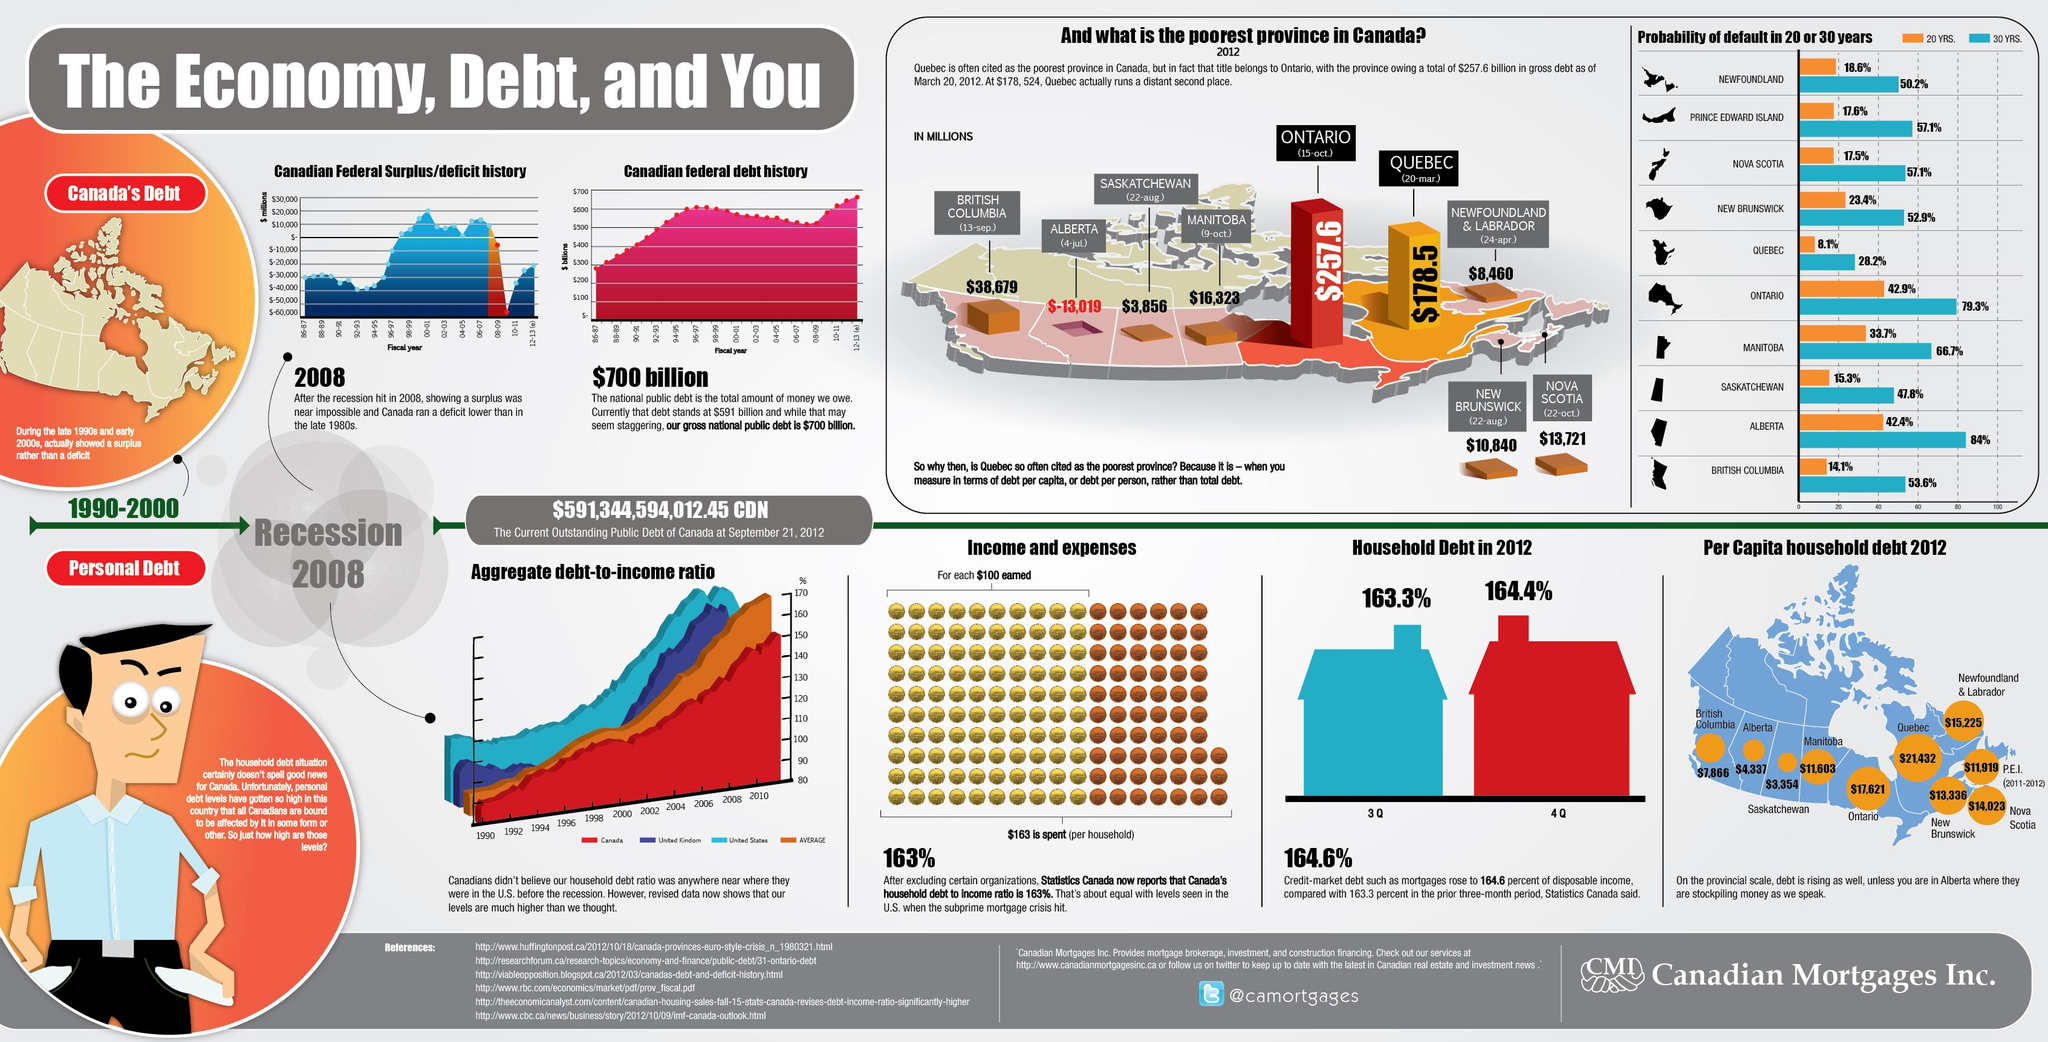Identify some key points in this picture. Alberta was the Canadian province with the least amount of per capita household debt in 2012. In 2012, the per capita household debt in Alberta was $4,337. According to data from 2012, Newfoundland & Labrador had the second highest per capita household debt among the provinces in Canada. In 2012, Quebec had the highest per capita household debt among the Canadian provinces. The probability of default of Ontario in 30 years is estimated to be 79.3%. 